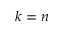Convert formula to latex. <formula><loc_0><loc_0><loc_500><loc_500>k = n</formula> 